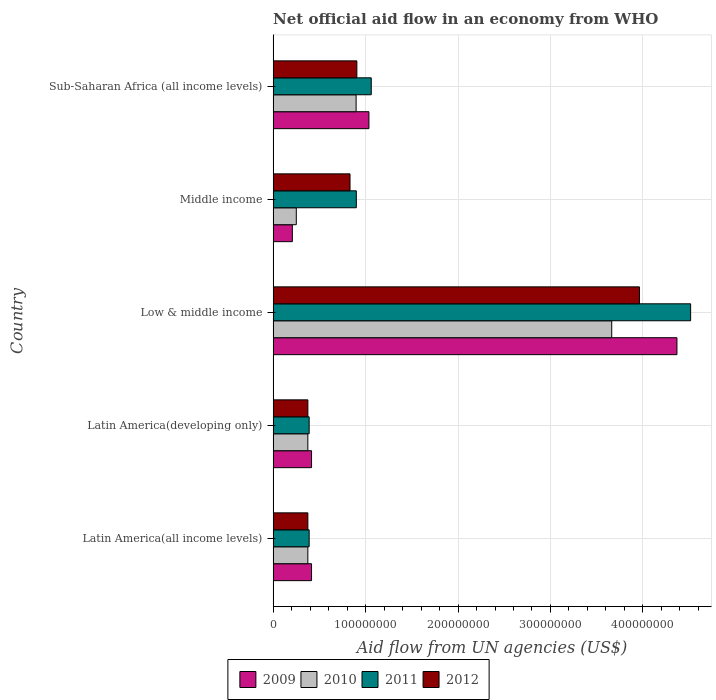How many groups of bars are there?
Ensure brevity in your answer.  5. Are the number of bars on each tick of the Y-axis equal?
Your answer should be very brief. Yes. How many bars are there on the 4th tick from the bottom?
Give a very brief answer. 4. What is the label of the 4th group of bars from the top?
Your answer should be very brief. Latin America(developing only). In how many cases, is the number of bars for a given country not equal to the number of legend labels?
Make the answer very short. 0. What is the net official aid flow in 2010 in Low & middle income?
Provide a succinct answer. 3.66e+08. Across all countries, what is the maximum net official aid flow in 2010?
Provide a succinct answer. 3.66e+08. Across all countries, what is the minimum net official aid flow in 2011?
Provide a short and direct response. 3.90e+07. In which country was the net official aid flow in 2012 minimum?
Your response must be concise. Latin America(all income levels). What is the total net official aid flow in 2012 in the graph?
Provide a short and direct response. 6.45e+08. What is the difference between the net official aid flow in 2011 in Latin America(developing only) and the net official aid flow in 2009 in Middle income?
Your answer should be very brief. 1.82e+07. What is the average net official aid flow in 2012 per country?
Offer a terse response. 1.29e+08. What is the difference between the net official aid flow in 2009 and net official aid flow in 2010 in Latin America(all income levels)?
Ensure brevity in your answer.  4.01e+06. In how many countries, is the net official aid flow in 2012 greater than 260000000 US$?
Provide a succinct answer. 1. Is the difference between the net official aid flow in 2009 in Latin America(all income levels) and Latin America(developing only) greater than the difference between the net official aid flow in 2010 in Latin America(all income levels) and Latin America(developing only)?
Offer a very short reply. No. What is the difference between the highest and the second highest net official aid flow in 2010?
Your answer should be very brief. 2.76e+08. What is the difference between the highest and the lowest net official aid flow in 2012?
Ensure brevity in your answer.  3.59e+08. Are all the bars in the graph horizontal?
Provide a short and direct response. Yes. Are the values on the major ticks of X-axis written in scientific E-notation?
Provide a short and direct response. No. Does the graph contain any zero values?
Offer a very short reply. No. Where does the legend appear in the graph?
Your response must be concise. Bottom center. How are the legend labels stacked?
Your response must be concise. Horizontal. What is the title of the graph?
Offer a very short reply. Net official aid flow in an economy from WHO. Does "1971" appear as one of the legend labels in the graph?
Offer a terse response. No. What is the label or title of the X-axis?
Make the answer very short. Aid flow from UN agencies (US$). What is the Aid flow from UN agencies (US$) of 2009 in Latin America(all income levels)?
Your answer should be compact. 4.16e+07. What is the Aid flow from UN agencies (US$) in 2010 in Latin America(all income levels)?
Your response must be concise. 3.76e+07. What is the Aid flow from UN agencies (US$) of 2011 in Latin America(all income levels)?
Ensure brevity in your answer.  3.90e+07. What is the Aid flow from UN agencies (US$) in 2012 in Latin America(all income levels)?
Make the answer very short. 3.76e+07. What is the Aid flow from UN agencies (US$) in 2009 in Latin America(developing only)?
Your answer should be compact. 4.16e+07. What is the Aid flow from UN agencies (US$) of 2010 in Latin America(developing only)?
Give a very brief answer. 3.76e+07. What is the Aid flow from UN agencies (US$) of 2011 in Latin America(developing only)?
Your response must be concise. 3.90e+07. What is the Aid flow from UN agencies (US$) of 2012 in Latin America(developing only)?
Make the answer very short. 3.76e+07. What is the Aid flow from UN agencies (US$) of 2009 in Low & middle income?
Provide a succinct answer. 4.37e+08. What is the Aid flow from UN agencies (US$) of 2010 in Low & middle income?
Ensure brevity in your answer.  3.66e+08. What is the Aid flow from UN agencies (US$) of 2011 in Low & middle income?
Provide a short and direct response. 4.52e+08. What is the Aid flow from UN agencies (US$) in 2012 in Low & middle income?
Your answer should be very brief. 3.96e+08. What is the Aid flow from UN agencies (US$) of 2009 in Middle income?
Make the answer very short. 2.08e+07. What is the Aid flow from UN agencies (US$) of 2010 in Middle income?
Make the answer very short. 2.51e+07. What is the Aid flow from UN agencies (US$) of 2011 in Middle income?
Give a very brief answer. 9.00e+07. What is the Aid flow from UN agencies (US$) of 2012 in Middle income?
Provide a succinct answer. 8.32e+07. What is the Aid flow from UN agencies (US$) in 2009 in Sub-Saharan Africa (all income levels)?
Your answer should be very brief. 1.04e+08. What is the Aid flow from UN agencies (US$) of 2010 in Sub-Saharan Africa (all income levels)?
Make the answer very short. 8.98e+07. What is the Aid flow from UN agencies (US$) in 2011 in Sub-Saharan Africa (all income levels)?
Provide a succinct answer. 1.06e+08. What is the Aid flow from UN agencies (US$) of 2012 in Sub-Saharan Africa (all income levels)?
Your answer should be compact. 9.06e+07. Across all countries, what is the maximum Aid flow from UN agencies (US$) in 2009?
Offer a very short reply. 4.37e+08. Across all countries, what is the maximum Aid flow from UN agencies (US$) of 2010?
Ensure brevity in your answer.  3.66e+08. Across all countries, what is the maximum Aid flow from UN agencies (US$) in 2011?
Make the answer very short. 4.52e+08. Across all countries, what is the maximum Aid flow from UN agencies (US$) of 2012?
Make the answer very short. 3.96e+08. Across all countries, what is the minimum Aid flow from UN agencies (US$) of 2009?
Make the answer very short. 2.08e+07. Across all countries, what is the minimum Aid flow from UN agencies (US$) in 2010?
Give a very brief answer. 2.51e+07. Across all countries, what is the minimum Aid flow from UN agencies (US$) in 2011?
Give a very brief answer. 3.90e+07. Across all countries, what is the minimum Aid flow from UN agencies (US$) of 2012?
Give a very brief answer. 3.76e+07. What is the total Aid flow from UN agencies (US$) in 2009 in the graph?
Ensure brevity in your answer.  6.44e+08. What is the total Aid flow from UN agencies (US$) in 2010 in the graph?
Offer a terse response. 5.56e+08. What is the total Aid flow from UN agencies (US$) of 2011 in the graph?
Your response must be concise. 7.26e+08. What is the total Aid flow from UN agencies (US$) of 2012 in the graph?
Your answer should be very brief. 6.45e+08. What is the difference between the Aid flow from UN agencies (US$) of 2010 in Latin America(all income levels) and that in Latin America(developing only)?
Keep it short and to the point. 0. What is the difference between the Aid flow from UN agencies (US$) in 2009 in Latin America(all income levels) and that in Low & middle income?
Provide a succinct answer. -3.95e+08. What is the difference between the Aid flow from UN agencies (US$) of 2010 in Latin America(all income levels) and that in Low & middle income?
Your answer should be very brief. -3.29e+08. What is the difference between the Aid flow from UN agencies (US$) of 2011 in Latin America(all income levels) and that in Low & middle income?
Keep it short and to the point. -4.13e+08. What is the difference between the Aid flow from UN agencies (US$) in 2012 in Latin America(all income levels) and that in Low & middle income?
Give a very brief answer. -3.59e+08. What is the difference between the Aid flow from UN agencies (US$) in 2009 in Latin America(all income levels) and that in Middle income?
Offer a very short reply. 2.08e+07. What is the difference between the Aid flow from UN agencies (US$) in 2010 in Latin America(all income levels) and that in Middle income?
Keep it short and to the point. 1.25e+07. What is the difference between the Aid flow from UN agencies (US$) in 2011 in Latin America(all income levels) and that in Middle income?
Provide a short and direct response. -5.10e+07. What is the difference between the Aid flow from UN agencies (US$) of 2012 in Latin America(all income levels) and that in Middle income?
Make the answer very short. -4.56e+07. What is the difference between the Aid flow from UN agencies (US$) in 2009 in Latin America(all income levels) and that in Sub-Saharan Africa (all income levels)?
Your response must be concise. -6.20e+07. What is the difference between the Aid flow from UN agencies (US$) in 2010 in Latin America(all income levels) and that in Sub-Saharan Africa (all income levels)?
Offer a very short reply. -5.22e+07. What is the difference between the Aid flow from UN agencies (US$) of 2011 in Latin America(all income levels) and that in Sub-Saharan Africa (all income levels)?
Ensure brevity in your answer.  -6.72e+07. What is the difference between the Aid flow from UN agencies (US$) of 2012 in Latin America(all income levels) and that in Sub-Saharan Africa (all income levels)?
Offer a very short reply. -5.30e+07. What is the difference between the Aid flow from UN agencies (US$) in 2009 in Latin America(developing only) and that in Low & middle income?
Your answer should be compact. -3.95e+08. What is the difference between the Aid flow from UN agencies (US$) of 2010 in Latin America(developing only) and that in Low & middle income?
Offer a terse response. -3.29e+08. What is the difference between the Aid flow from UN agencies (US$) of 2011 in Latin America(developing only) and that in Low & middle income?
Offer a terse response. -4.13e+08. What is the difference between the Aid flow from UN agencies (US$) in 2012 in Latin America(developing only) and that in Low & middle income?
Offer a terse response. -3.59e+08. What is the difference between the Aid flow from UN agencies (US$) of 2009 in Latin America(developing only) and that in Middle income?
Ensure brevity in your answer.  2.08e+07. What is the difference between the Aid flow from UN agencies (US$) of 2010 in Latin America(developing only) and that in Middle income?
Give a very brief answer. 1.25e+07. What is the difference between the Aid flow from UN agencies (US$) of 2011 in Latin America(developing only) and that in Middle income?
Ensure brevity in your answer.  -5.10e+07. What is the difference between the Aid flow from UN agencies (US$) of 2012 in Latin America(developing only) and that in Middle income?
Your answer should be compact. -4.56e+07. What is the difference between the Aid flow from UN agencies (US$) in 2009 in Latin America(developing only) and that in Sub-Saharan Africa (all income levels)?
Keep it short and to the point. -6.20e+07. What is the difference between the Aid flow from UN agencies (US$) in 2010 in Latin America(developing only) and that in Sub-Saharan Africa (all income levels)?
Your answer should be compact. -5.22e+07. What is the difference between the Aid flow from UN agencies (US$) in 2011 in Latin America(developing only) and that in Sub-Saharan Africa (all income levels)?
Provide a short and direct response. -6.72e+07. What is the difference between the Aid flow from UN agencies (US$) of 2012 in Latin America(developing only) and that in Sub-Saharan Africa (all income levels)?
Ensure brevity in your answer.  -5.30e+07. What is the difference between the Aid flow from UN agencies (US$) in 2009 in Low & middle income and that in Middle income?
Offer a terse response. 4.16e+08. What is the difference between the Aid flow from UN agencies (US$) of 2010 in Low & middle income and that in Middle income?
Ensure brevity in your answer.  3.41e+08. What is the difference between the Aid flow from UN agencies (US$) in 2011 in Low & middle income and that in Middle income?
Provide a succinct answer. 3.62e+08. What is the difference between the Aid flow from UN agencies (US$) in 2012 in Low & middle income and that in Middle income?
Offer a terse response. 3.13e+08. What is the difference between the Aid flow from UN agencies (US$) in 2009 in Low & middle income and that in Sub-Saharan Africa (all income levels)?
Offer a very short reply. 3.33e+08. What is the difference between the Aid flow from UN agencies (US$) of 2010 in Low & middle income and that in Sub-Saharan Africa (all income levels)?
Your response must be concise. 2.76e+08. What is the difference between the Aid flow from UN agencies (US$) in 2011 in Low & middle income and that in Sub-Saharan Africa (all income levels)?
Offer a terse response. 3.45e+08. What is the difference between the Aid flow from UN agencies (US$) of 2012 in Low & middle income and that in Sub-Saharan Africa (all income levels)?
Provide a short and direct response. 3.06e+08. What is the difference between the Aid flow from UN agencies (US$) in 2009 in Middle income and that in Sub-Saharan Africa (all income levels)?
Give a very brief answer. -8.28e+07. What is the difference between the Aid flow from UN agencies (US$) in 2010 in Middle income and that in Sub-Saharan Africa (all income levels)?
Your response must be concise. -6.47e+07. What is the difference between the Aid flow from UN agencies (US$) of 2011 in Middle income and that in Sub-Saharan Africa (all income levels)?
Make the answer very short. -1.62e+07. What is the difference between the Aid flow from UN agencies (US$) of 2012 in Middle income and that in Sub-Saharan Africa (all income levels)?
Ensure brevity in your answer.  -7.39e+06. What is the difference between the Aid flow from UN agencies (US$) in 2009 in Latin America(all income levels) and the Aid flow from UN agencies (US$) in 2010 in Latin America(developing only)?
Make the answer very short. 4.01e+06. What is the difference between the Aid flow from UN agencies (US$) of 2009 in Latin America(all income levels) and the Aid flow from UN agencies (US$) of 2011 in Latin America(developing only)?
Offer a very short reply. 2.59e+06. What is the difference between the Aid flow from UN agencies (US$) of 2009 in Latin America(all income levels) and the Aid flow from UN agencies (US$) of 2012 in Latin America(developing only)?
Ensure brevity in your answer.  3.99e+06. What is the difference between the Aid flow from UN agencies (US$) in 2010 in Latin America(all income levels) and the Aid flow from UN agencies (US$) in 2011 in Latin America(developing only)?
Provide a succinct answer. -1.42e+06. What is the difference between the Aid flow from UN agencies (US$) in 2011 in Latin America(all income levels) and the Aid flow from UN agencies (US$) in 2012 in Latin America(developing only)?
Your answer should be compact. 1.40e+06. What is the difference between the Aid flow from UN agencies (US$) in 2009 in Latin America(all income levels) and the Aid flow from UN agencies (US$) in 2010 in Low & middle income?
Your response must be concise. -3.25e+08. What is the difference between the Aid flow from UN agencies (US$) of 2009 in Latin America(all income levels) and the Aid flow from UN agencies (US$) of 2011 in Low & middle income?
Ensure brevity in your answer.  -4.10e+08. What is the difference between the Aid flow from UN agencies (US$) in 2009 in Latin America(all income levels) and the Aid flow from UN agencies (US$) in 2012 in Low & middle income?
Provide a succinct answer. -3.55e+08. What is the difference between the Aid flow from UN agencies (US$) of 2010 in Latin America(all income levels) and the Aid flow from UN agencies (US$) of 2011 in Low & middle income?
Provide a short and direct response. -4.14e+08. What is the difference between the Aid flow from UN agencies (US$) of 2010 in Latin America(all income levels) and the Aid flow from UN agencies (US$) of 2012 in Low & middle income?
Provide a succinct answer. -3.59e+08. What is the difference between the Aid flow from UN agencies (US$) in 2011 in Latin America(all income levels) and the Aid flow from UN agencies (US$) in 2012 in Low & middle income?
Offer a very short reply. -3.57e+08. What is the difference between the Aid flow from UN agencies (US$) of 2009 in Latin America(all income levels) and the Aid flow from UN agencies (US$) of 2010 in Middle income?
Give a very brief answer. 1.65e+07. What is the difference between the Aid flow from UN agencies (US$) in 2009 in Latin America(all income levels) and the Aid flow from UN agencies (US$) in 2011 in Middle income?
Your response must be concise. -4.84e+07. What is the difference between the Aid flow from UN agencies (US$) in 2009 in Latin America(all income levels) and the Aid flow from UN agencies (US$) in 2012 in Middle income?
Your answer should be very brief. -4.16e+07. What is the difference between the Aid flow from UN agencies (US$) of 2010 in Latin America(all income levels) and the Aid flow from UN agencies (US$) of 2011 in Middle income?
Keep it short and to the point. -5.24e+07. What is the difference between the Aid flow from UN agencies (US$) of 2010 in Latin America(all income levels) and the Aid flow from UN agencies (US$) of 2012 in Middle income?
Keep it short and to the point. -4.56e+07. What is the difference between the Aid flow from UN agencies (US$) in 2011 in Latin America(all income levels) and the Aid flow from UN agencies (US$) in 2012 in Middle income?
Ensure brevity in your answer.  -4.42e+07. What is the difference between the Aid flow from UN agencies (US$) in 2009 in Latin America(all income levels) and the Aid flow from UN agencies (US$) in 2010 in Sub-Saharan Africa (all income levels)?
Your answer should be very brief. -4.82e+07. What is the difference between the Aid flow from UN agencies (US$) in 2009 in Latin America(all income levels) and the Aid flow from UN agencies (US$) in 2011 in Sub-Saharan Africa (all income levels)?
Ensure brevity in your answer.  -6.46e+07. What is the difference between the Aid flow from UN agencies (US$) in 2009 in Latin America(all income levels) and the Aid flow from UN agencies (US$) in 2012 in Sub-Saharan Africa (all income levels)?
Provide a succinct answer. -4.90e+07. What is the difference between the Aid flow from UN agencies (US$) of 2010 in Latin America(all income levels) and the Aid flow from UN agencies (US$) of 2011 in Sub-Saharan Africa (all income levels)?
Provide a succinct answer. -6.86e+07. What is the difference between the Aid flow from UN agencies (US$) of 2010 in Latin America(all income levels) and the Aid flow from UN agencies (US$) of 2012 in Sub-Saharan Africa (all income levels)?
Your response must be concise. -5.30e+07. What is the difference between the Aid flow from UN agencies (US$) of 2011 in Latin America(all income levels) and the Aid flow from UN agencies (US$) of 2012 in Sub-Saharan Africa (all income levels)?
Your answer should be very brief. -5.16e+07. What is the difference between the Aid flow from UN agencies (US$) in 2009 in Latin America(developing only) and the Aid flow from UN agencies (US$) in 2010 in Low & middle income?
Give a very brief answer. -3.25e+08. What is the difference between the Aid flow from UN agencies (US$) in 2009 in Latin America(developing only) and the Aid flow from UN agencies (US$) in 2011 in Low & middle income?
Offer a terse response. -4.10e+08. What is the difference between the Aid flow from UN agencies (US$) in 2009 in Latin America(developing only) and the Aid flow from UN agencies (US$) in 2012 in Low & middle income?
Keep it short and to the point. -3.55e+08. What is the difference between the Aid flow from UN agencies (US$) of 2010 in Latin America(developing only) and the Aid flow from UN agencies (US$) of 2011 in Low & middle income?
Ensure brevity in your answer.  -4.14e+08. What is the difference between the Aid flow from UN agencies (US$) of 2010 in Latin America(developing only) and the Aid flow from UN agencies (US$) of 2012 in Low & middle income?
Offer a terse response. -3.59e+08. What is the difference between the Aid flow from UN agencies (US$) in 2011 in Latin America(developing only) and the Aid flow from UN agencies (US$) in 2012 in Low & middle income?
Provide a short and direct response. -3.57e+08. What is the difference between the Aid flow from UN agencies (US$) of 2009 in Latin America(developing only) and the Aid flow from UN agencies (US$) of 2010 in Middle income?
Make the answer very short. 1.65e+07. What is the difference between the Aid flow from UN agencies (US$) in 2009 in Latin America(developing only) and the Aid flow from UN agencies (US$) in 2011 in Middle income?
Your response must be concise. -4.84e+07. What is the difference between the Aid flow from UN agencies (US$) of 2009 in Latin America(developing only) and the Aid flow from UN agencies (US$) of 2012 in Middle income?
Provide a succinct answer. -4.16e+07. What is the difference between the Aid flow from UN agencies (US$) of 2010 in Latin America(developing only) and the Aid flow from UN agencies (US$) of 2011 in Middle income?
Your answer should be very brief. -5.24e+07. What is the difference between the Aid flow from UN agencies (US$) of 2010 in Latin America(developing only) and the Aid flow from UN agencies (US$) of 2012 in Middle income?
Offer a terse response. -4.56e+07. What is the difference between the Aid flow from UN agencies (US$) in 2011 in Latin America(developing only) and the Aid flow from UN agencies (US$) in 2012 in Middle income?
Give a very brief answer. -4.42e+07. What is the difference between the Aid flow from UN agencies (US$) of 2009 in Latin America(developing only) and the Aid flow from UN agencies (US$) of 2010 in Sub-Saharan Africa (all income levels)?
Ensure brevity in your answer.  -4.82e+07. What is the difference between the Aid flow from UN agencies (US$) of 2009 in Latin America(developing only) and the Aid flow from UN agencies (US$) of 2011 in Sub-Saharan Africa (all income levels)?
Your answer should be very brief. -6.46e+07. What is the difference between the Aid flow from UN agencies (US$) of 2009 in Latin America(developing only) and the Aid flow from UN agencies (US$) of 2012 in Sub-Saharan Africa (all income levels)?
Offer a terse response. -4.90e+07. What is the difference between the Aid flow from UN agencies (US$) in 2010 in Latin America(developing only) and the Aid flow from UN agencies (US$) in 2011 in Sub-Saharan Africa (all income levels)?
Ensure brevity in your answer.  -6.86e+07. What is the difference between the Aid flow from UN agencies (US$) of 2010 in Latin America(developing only) and the Aid flow from UN agencies (US$) of 2012 in Sub-Saharan Africa (all income levels)?
Keep it short and to the point. -5.30e+07. What is the difference between the Aid flow from UN agencies (US$) in 2011 in Latin America(developing only) and the Aid flow from UN agencies (US$) in 2012 in Sub-Saharan Africa (all income levels)?
Offer a terse response. -5.16e+07. What is the difference between the Aid flow from UN agencies (US$) in 2009 in Low & middle income and the Aid flow from UN agencies (US$) in 2010 in Middle income?
Offer a terse response. 4.12e+08. What is the difference between the Aid flow from UN agencies (US$) in 2009 in Low & middle income and the Aid flow from UN agencies (US$) in 2011 in Middle income?
Offer a very short reply. 3.47e+08. What is the difference between the Aid flow from UN agencies (US$) in 2009 in Low & middle income and the Aid flow from UN agencies (US$) in 2012 in Middle income?
Offer a very short reply. 3.54e+08. What is the difference between the Aid flow from UN agencies (US$) in 2010 in Low & middle income and the Aid flow from UN agencies (US$) in 2011 in Middle income?
Your answer should be compact. 2.76e+08. What is the difference between the Aid flow from UN agencies (US$) of 2010 in Low & middle income and the Aid flow from UN agencies (US$) of 2012 in Middle income?
Make the answer very short. 2.83e+08. What is the difference between the Aid flow from UN agencies (US$) of 2011 in Low & middle income and the Aid flow from UN agencies (US$) of 2012 in Middle income?
Provide a short and direct response. 3.68e+08. What is the difference between the Aid flow from UN agencies (US$) in 2009 in Low & middle income and the Aid flow from UN agencies (US$) in 2010 in Sub-Saharan Africa (all income levels)?
Your answer should be compact. 3.47e+08. What is the difference between the Aid flow from UN agencies (US$) in 2009 in Low & middle income and the Aid flow from UN agencies (US$) in 2011 in Sub-Saharan Africa (all income levels)?
Your answer should be very brief. 3.31e+08. What is the difference between the Aid flow from UN agencies (US$) of 2009 in Low & middle income and the Aid flow from UN agencies (US$) of 2012 in Sub-Saharan Africa (all income levels)?
Offer a terse response. 3.46e+08. What is the difference between the Aid flow from UN agencies (US$) of 2010 in Low & middle income and the Aid flow from UN agencies (US$) of 2011 in Sub-Saharan Africa (all income levels)?
Make the answer very short. 2.60e+08. What is the difference between the Aid flow from UN agencies (US$) in 2010 in Low & middle income and the Aid flow from UN agencies (US$) in 2012 in Sub-Saharan Africa (all income levels)?
Ensure brevity in your answer.  2.76e+08. What is the difference between the Aid flow from UN agencies (US$) in 2011 in Low & middle income and the Aid flow from UN agencies (US$) in 2012 in Sub-Saharan Africa (all income levels)?
Give a very brief answer. 3.61e+08. What is the difference between the Aid flow from UN agencies (US$) in 2009 in Middle income and the Aid flow from UN agencies (US$) in 2010 in Sub-Saharan Africa (all income levels)?
Your answer should be very brief. -6.90e+07. What is the difference between the Aid flow from UN agencies (US$) in 2009 in Middle income and the Aid flow from UN agencies (US$) in 2011 in Sub-Saharan Africa (all income levels)?
Ensure brevity in your answer.  -8.54e+07. What is the difference between the Aid flow from UN agencies (US$) of 2009 in Middle income and the Aid flow from UN agencies (US$) of 2012 in Sub-Saharan Africa (all income levels)?
Provide a short and direct response. -6.98e+07. What is the difference between the Aid flow from UN agencies (US$) in 2010 in Middle income and the Aid flow from UN agencies (US$) in 2011 in Sub-Saharan Africa (all income levels)?
Give a very brief answer. -8.11e+07. What is the difference between the Aid flow from UN agencies (US$) of 2010 in Middle income and the Aid flow from UN agencies (US$) of 2012 in Sub-Saharan Africa (all income levels)?
Keep it short and to the point. -6.55e+07. What is the difference between the Aid flow from UN agencies (US$) in 2011 in Middle income and the Aid flow from UN agencies (US$) in 2012 in Sub-Saharan Africa (all income levels)?
Your answer should be very brief. -5.90e+05. What is the average Aid flow from UN agencies (US$) in 2009 per country?
Ensure brevity in your answer.  1.29e+08. What is the average Aid flow from UN agencies (US$) in 2010 per country?
Provide a succinct answer. 1.11e+08. What is the average Aid flow from UN agencies (US$) of 2011 per country?
Ensure brevity in your answer.  1.45e+08. What is the average Aid flow from UN agencies (US$) of 2012 per country?
Ensure brevity in your answer.  1.29e+08. What is the difference between the Aid flow from UN agencies (US$) in 2009 and Aid flow from UN agencies (US$) in 2010 in Latin America(all income levels)?
Offer a very short reply. 4.01e+06. What is the difference between the Aid flow from UN agencies (US$) in 2009 and Aid flow from UN agencies (US$) in 2011 in Latin America(all income levels)?
Your answer should be compact. 2.59e+06. What is the difference between the Aid flow from UN agencies (US$) in 2009 and Aid flow from UN agencies (US$) in 2012 in Latin America(all income levels)?
Keep it short and to the point. 3.99e+06. What is the difference between the Aid flow from UN agencies (US$) of 2010 and Aid flow from UN agencies (US$) of 2011 in Latin America(all income levels)?
Make the answer very short. -1.42e+06. What is the difference between the Aid flow from UN agencies (US$) in 2010 and Aid flow from UN agencies (US$) in 2012 in Latin America(all income levels)?
Your answer should be very brief. -2.00e+04. What is the difference between the Aid flow from UN agencies (US$) of 2011 and Aid flow from UN agencies (US$) of 2012 in Latin America(all income levels)?
Provide a short and direct response. 1.40e+06. What is the difference between the Aid flow from UN agencies (US$) of 2009 and Aid flow from UN agencies (US$) of 2010 in Latin America(developing only)?
Make the answer very short. 4.01e+06. What is the difference between the Aid flow from UN agencies (US$) in 2009 and Aid flow from UN agencies (US$) in 2011 in Latin America(developing only)?
Your answer should be compact. 2.59e+06. What is the difference between the Aid flow from UN agencies (US$) in 2009 and Aid flow from UN agencies (US$) in 2012 in Latin America(developing only)?
Your answer should be very brief. 3.99e+06. What is the difference between the Aid flow from UN agencies (US$) of 2010 and Aid flow from UN agencies (US$) of 2011 in Latin America(developing only)?
Your answer should be very brief. -1.42e+06. What is the difference between the Aid flow from UN agencies (US$) of 2010 and Aid flow from UN agencies (US$) of 2012 in Latin America(developing only)?
Provide a succinct answer. -2.00e+04. What is the difference between the Aid flow from UN agencies (US$) of 2011 and Aid flow from UN agencies (US$) of 2012 in Latin America(developing only)?
Your response must be concise. 1.40e+06. What is the difference between the Aid flow from UN agencies (US$) in 2009 and Aid flow from UN agencies (US$) in 2010 in Low & middle income?
Offer a terse response. 7.06e+07. What is the difference between the Aid flow from UN agencies (US$) in 2009 and Aid flow from UN agencies (US$) in 2011 in Low & middle income?
Give a very brief answer. -1.48e+07. What is the difference between the Aid flow from UN agencies (US$) of 2009 and Aid flow from UN agencies (US$) of 2012 in Low & middle income?
Offer a very short reply. 4.05e+07. What is the difference between the Aid flow from UN agencies (US$) of 2010 and Aid flow from UN agencies (US$) of 2011 in Low & middle income?
Offer a very short reply. -8.54e+07. What is the difference between the Aid flow from UN agencies (US$) of 2010 and Aid flow from UN agencies (US$) of 2012 in Low & middle income?
Provide a succinct answer. -3.00e+07. What is the difference between the Aid flow from UN agencies (US$) in 2011 and Aid flow from UN agencies (US$) in 2012 in Low & middle income?
Keep it short and to the point. 5.53e+07. What is the difference between the Aid flow from UN agencies (US$) of 2009 and Aid flow from UN agencies (US$) of 2010 in Middle income?
Your answer should be very brief. -4.27e+06. What is the difference between the Aid flow from UN agencies (US$) of 2009 and Aid flow from UN agencies (US$) of 2011 in Middle income?
Ensure brevity in your answer.  -6.92e+07. What is the difference between the Aid flow from UN agencies (US$) in 2009 and Aid flow from UN agencies (US$) in 2012 in Middle income?
Your answer should be very brief. -6.24e+07. What is the difference between the Aid flow from UN agencies (US$) of 2010 and Aid flow from UN agencies (US$) of 2011 in Middle income?
Your response must be concise. -6.49e+07. What is the difference between the Aid flow from UN agencies (US$) in 2010 and Aid flow from UN agencies (US$) in 2012 in Middle income?
Offer a terse response. -5.81e+07. What is the difference between the Aid flow from UN agencies (US$) in 2011 and Aid flow from UN agencies (US$) in 2012 in Middle income?
Offer a very short reply. 6.80e+06. What is the difference between the Aid flow from UN agencies (US$) of 2009 and Aid flow from UN agencies (US$) of 2010 in Sub-Saharan Africa (all income levels)?
Provide a succinct answer. 1.39e+07. What is the difference between the Aid flow from UN agencies (US$) of 2009 and Aid flow from UN agencies (US$) of 2011 in Sub-Saharan Africa (all income levels)?
Provide a succinct answer. -2.53e+06. What is the difference between the Aid flow from UN agencies (US$) in 2009 and Aid flow from UN agencies (US$) in 2012 in Sub-Saharan Africa (all income levels)?
Give a very brief answer. 1.30e+07. What is the difference between the Aid flow from UN agencies (US$) in 2010 and Aid flow from UN agencies (US$) in 2011 in Sub-Saharan Africa (all income levels)?
Your response must be concise. -1.64e+07. What is the difference between the Aid flow from UN agencies (US$) of 2010 and Aid flow from UN agencies (US$) of 2012 in Sub-Saharan Africa (all income levels)?
Ensure brevity in your answer.  -8.10e+05. What is the difference between the Aid flow from UN agencies (US$) of 2011 and Aid flow from UN agencies (US$) of 2012 in Sub-Saharan Africa (all income levels)?
Offer a terse response. 1.56e+07. What is the ratio of the Aid flow from UN agencies (US$) in 2010 in Latin America(all income levels) to that in Latin America(developing only)?
Your answer should be compact. 1. What is the ratio of the Aid flow from UN agencies (US$) of 2011 in Latin America(all income levels) to that in Latin America(developing only)?
Keep it short and to the point. 1. What is the ratio of the Aid flow from UN agencies (US$) in 2012 in Latin America(all income levels) to that in Latin America(developing only)?
Provide a succinct answer. 1. What is the ratio of the Aid flow from UN agencies (US$) in 2009 in Latin America(all income levels) to that in Low & middle income?
Give a very brief answer. 0.1. What is the ratio of the Aid flow from UN agencies (US$) in 2010 in Latin America(all income levels) to that in Low & middle income?
Ensure brevity in your answer.  0.1. What is the ratio of the Aid flow from UN agencies (US$) in 2011 in Latin America(all income levels) to that in Low & middle income?
Offer a very short reply. 0.09. What is the ratio of the Aid flow from UN agencies (US$) in 2012 in Latin America(all income levels) to that in Low & middle income?
Provide a short and direct response. 0.09. What is the ratio of the Aid flow from UN agencies (US$) in 2009 in Latin America(all income levels) to that in Middle income?
Keep it short and to the point. 2. What is the ratio of the Aid flow from UN agencies (US$) of 2010 in Latin America(all income levels) to that in Middle income?
Offer a terse response. 1.5. What is the ratio of the Aid flow from UN agencies (US$) of 2011 in Latin America(all income levels) to that in Middle income?
Your response must be concise. 0.43. What is the ratio of the Aid flow from UN agencies (US$) of 2012 in Latin America(all income levels) to that in Middle income?
Offer a very short reply. 0.45. What is the ratio of the Aid flow from UN agencies (US$) in 2009 in Latin America(all income levels) to that in Sub-Saharan Africa (all income levels)?
Ensure brevity in your answer.  0.4. What is the ratio of the Aid flow from UN agencies (US$) of 2010 in Latin America(all income levels) to that in Sub-Saharan Africa (all income levels)?
Give a very brief answer. 0.42. What is the ratio of the Aid flow from UN agencies (US$) in 2011 in Latin America(all income levels) to that in Sub-Saharan Africa (all income levels)?
Provide a short and direct response. 0.37. What is the ratio of the Aid flow from UN agencies (US$) of 2012 in Latin America(all income levels) to that in Sub-Saharan Africa (all income levels)?
Provide a succinct answer. 0.41. What is the ratio of the Aid flow from UN agencies (US$) in 2009 in Latin America(developing only) to that in Low & middle income?
Ensure brevity in your answer.  0.1. What is the ratio of the Aid flow from UN agencies (US$) in 2010 in Latin America(developing only) to that in Low & middle income?
Provide a succinct answer. 0.1. What is the ratio of the Aid flow from UN agencies (US$) of 2011 in Latin America(developing only) to that in Low & middle income?
Provide a short and direct response. 0.09. What is the ratio of the Aid flow from UN agencies (US$) in 2012 in Latin America(developing only) to that in Low & middle income?
Your answer should be compact. 0.09. What is the ratio of the Aid flow from UN agencies (US$) in 2009 in Latin America(developing only) to that in Middle income?
Your answer should be very brief. 2. What is the ratio of the Aid flow from UN agencies (US$) of 2010 in Latin America(developing only) to that in Middle income?
Give a very brief answer. 1.5. What is the ratio of the Aid flow from UN agencies (US$) in 2011 in Latin America(developing only) to that in Middle income?
Provide a succinct answer. 0.43. What is the ratio of the Aid flow from UN agencies (US$) of 2012 in Latin America(developing only) to that in Middle income?
Ensure brevity in your answer.  0.45. What is the ratio of the Aid flow from UN agencies (US$) of 2009 in Latin America(developing only) to that in Sub-Saharan Africa (all income levels)?
Your answer should be very brief. 0.4. What is the ratio of the Aid flow from UN agencies (US$) of 2010 in Latin America(developing only) to that in Sub-Saharan Africa (all income levels)?
Keep it short and to the point. 0.42. What is the ratio of the Aid flow from UN agencies (US$) of 2011 in Latin America(developing only) to that in Sub-Saharan Africa (all income levels)?
Your answer should be compact. 0.37. What is the ratio of the Aid flow from UN agencies (US$) of 2012 in Latin America(developing only) to that in Sub-Saharan Africa (all income levels)?
Your answer should be very brief. 0.41. What is the ratio of the Aid flow from UN agencies (US$) of 2009 in Low & middle income to that in Middle income?
Provide a short and direct response. 21. What is the ratio of the Aid flow from UN agencies (US$) of 2010 in Low & middle income to that in Middle income?
Offer a very short reply. 14.61. What is the ratio of the Aid flow from UN agencies (US$) in 2011 in Low & middle income to that in Middle income?
Offer a terse response. 5.02. What is the ratio of the Aid flow from UN agencies (US$) of 2012 in Low & middle income to that in Middle income?
Your answer should be compact. 4.76. What is the ratio of the Aid flow from UN agencies (US$) of 2009 in Low & middle income to that in Sub-Saharan Africa (all income levels)?
Give a very brief answer. 4.22. What is the ratio of the Aid flow from UN agencies (US$) of 2010 in Low & middle income to that in Sub-Saharan Africa (all income levels)?
Your answer should be very brief. 4.08. What is the ratio of the Aid flow from UN agencies (US$) of 2011 in Low & middle income to that in Sub-Saharan Africa (all income levels)?
Give a very brief answer. 4.25. What is the ratio of the Aid flow from UN agencies (US$) in 2012 in Low & middle income to that in Sub-Saharan Africa (all income levels)?
Give a very brief answer. 4.38. What is the ratio of the Aid flow from UN agencies (US$) of 2009 in Middle income to that in Sub-Saharan Africa (all income levels)?
Make the answer very short. 0.2. What is the ratio of the Aid flow from UN agencies (US$) of 2010 in Middle income to that in Sub-Saharan Africa (all income levels)?
Provide a succinct answer. 0.28. What is the ratio of the Aid flow from UN agencies (US$) in 2011 in Middle income to that in Sub-Saharan Africa (all income levels)?
Your answer should be very brief. 0.85. What is the ratio of the Aid flow from UN agencies (US$) of 2012 in Middle income to that in Sub-Saharan Africa (all income levels)?
Make the answer very short. 0.92. What is the difference between the highest and the second highest Aid flow from UN agencies (US$) of 2009?
Give a very brief answer. 3.33e+08. What is the difference between the highest and the second highest Aid flow from UN agencies (US$) of 2010?
Ensure brevity in your answer.  2.76e+08. What is the difference between the highest and the second highest Aid flow from UN agencies (US$) in 2011?
Keep it short and to the point. 3.45e+08. What is the difference between the highest and the second highest Aid flow from UN agencies (US$) in 2012?
Your answer should be compact. 3.06e+08. What is the difference between the highest and the lowest Aid flow from UN agencies (US$) of 2009?
Your answer should be compact. 4.16e+08. What is the difference between the highest and the lowest Aid flow from UN agencies (US$) in 2010?
Give a very brief answer. 3.41e+08. What is the difference between the highest and the lowest Aid flow from UN agencies (US$) in 2011?
Offer a terse response. 4.13e+08. What is the difference between the highest and the lowest Aid flow from UN agencies (US$) of 2012?
Your response must be concise. 3.59e+08. 